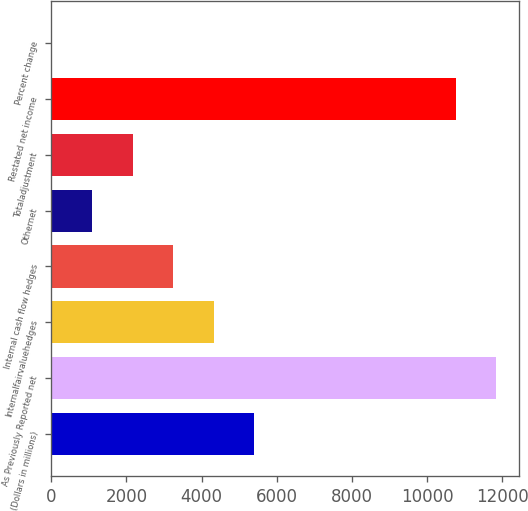<chart> <loc_0><loc_0><loc_500><loc_500><bar_chart><fcel>(Dollars in millions)<fcel>As Previously Reported net<fcel>Internalfairvaluehedges<fcel>Internal cash flow hedges<fcel>Othernet<fcel>Totaladjustment<fcel>Restated net income<fcel>Percent change<nl><fcel>5405.25<fcel>11843<fcel>4324.3<fcel>3243.35<fcel>1081.45<fcel>2162.4<fcel>10762<fcel>0.5<nl></chart> 